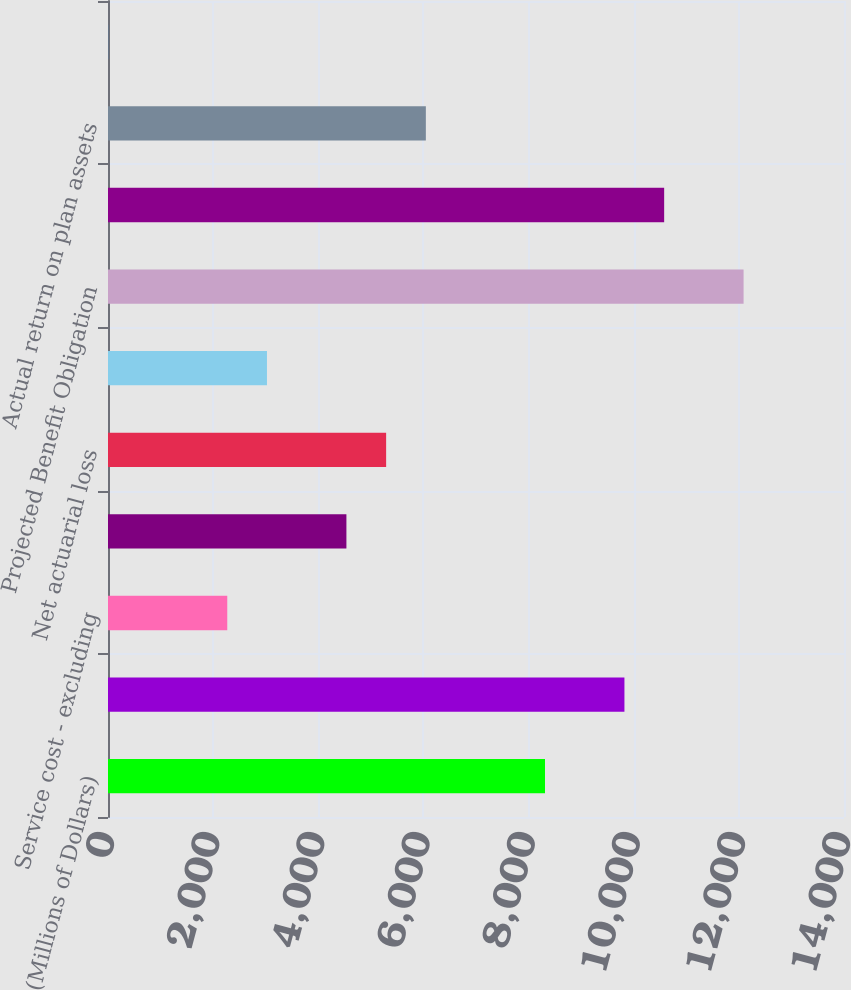Convert chart. <chart><loc_0><loc_0><loc_500><loc_500><bar_chart><fcel>(Millions of Dollars)<fcel>Projected benefit obligation<fcel>Service cost - excluding<fcel>Interest cost on projected<fcel>Net actuarial loss<fcel>Benefits paid<fcel>Projected Benefit Obligation<fcel>Fair value of plan assets at<fcel>Actual return on plan assets<fcel>Employer contributions<nl><fcel>8312.5<fcel>9823.5<fcel>2268.5<fcel>4535<fcel>5290.5<fcel>3024<fcel>12090<fcel>10579<fcel>6046<fcel>2<nl></chart> 